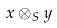Convert formula to latex. <formula><loc_0><loc_0><loc_500><loc_500>x \otimes _ { S } y</formula> 